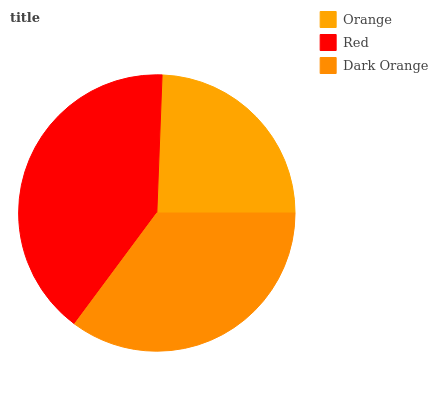Is Orange the minimum?
Answer yes or no. Yes. Is Red the maximum?
Answer yes or no. Yes. Is Dark Orange the minimum?
Answer yes or no. No. Is Dark Orange the maximum?
Answer yes or no. No. Is Red greater than Dark Orange?
Answer yes or no. Yes. Is Dark Orange less than Red?
Answer yes or no. Yes. Is Dark Orange greater than Red?
Answer yes or no. No. Is Red less than Dark Orange?
Answer yes or no. No. Is Dark Orange the high median?
Answer yes or no. Yes. Is Dark Orange the low median?
Answer yes or no. Yes. Is Red the high median?
Answer yes or no. No. Is Red the low median?
Answer yes or no. No. 